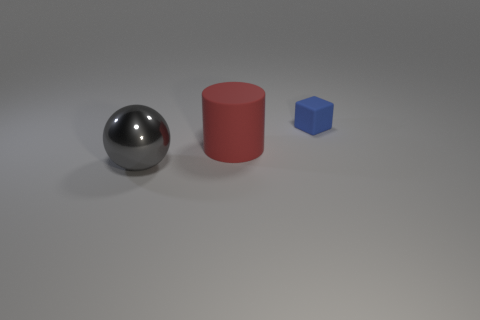There is a object that is right of the cylinder; is its color the same as the big object behind the large gray sphere?
Make the answer very short. No. The object in front of the rubber object that is on the left side of the matte thing right of the large rubber object is what shape?
Provide a short and direct response. Sphere. The object that is on the right side of the gray shiny object and in front of the small blue cube has what shape?
Give a very brief answer. Cylinder. There is a matte object on the left side of the object to the right of the big red thing; how many big gray metallic objects are in front of it?
Provide a short and direct response. 1. Are there any other things that are the same size as the metal sphere?
Provide a succinct answer. Yes. Is the material of the big thing right of the gray metallic ball the same as the large sphere?
Provide a short and direct response. No. What number of other things are the same color as the large sphere?
Ensure brevity in your answer.  0. Does the matte thing in front of the tiny cube have the same shape as the object that is behind the large rubber cylinder?
Your response must be concise. No. How many cubes are big red things or large gray objects?
Your answer should be very brief. 0. Is the number of big balls that are right of the blue thing less than the number of big blue rubber spheres?
Give a very brief answer. No. 